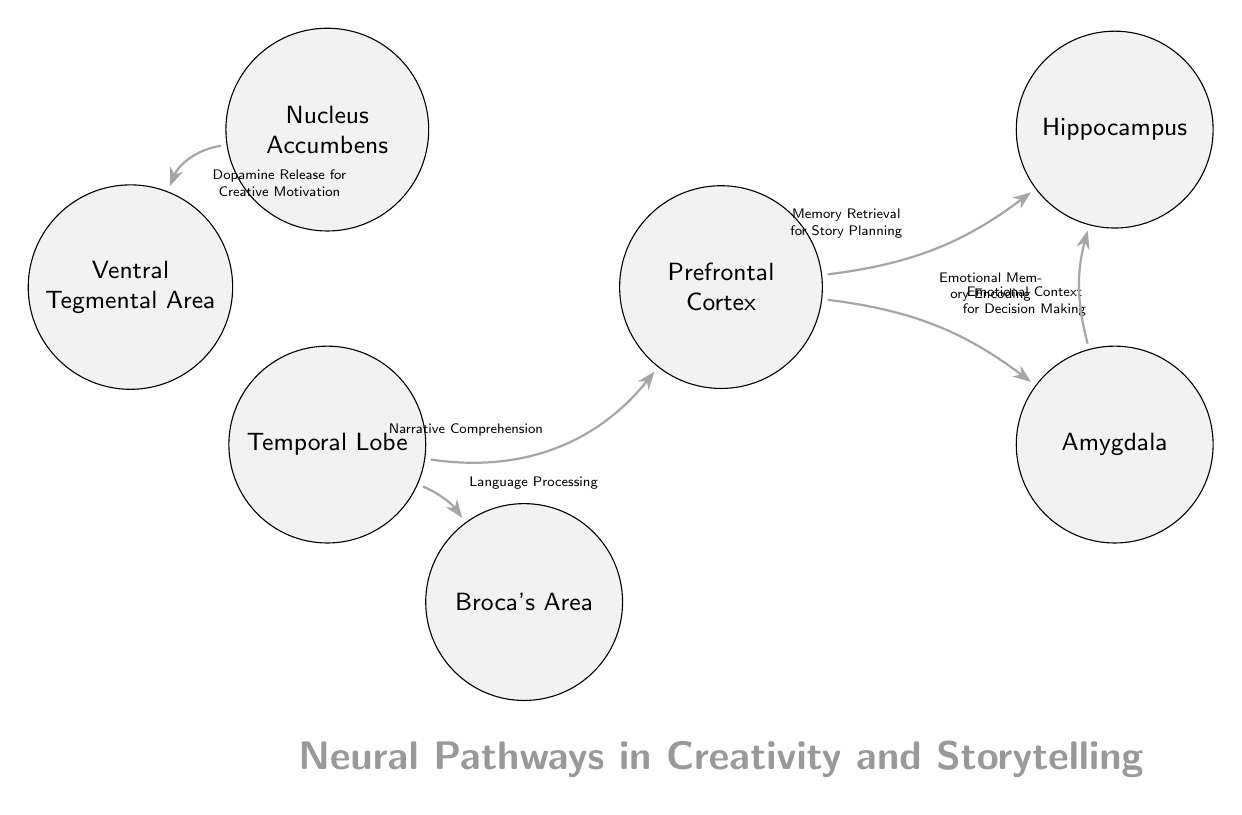What is the central brain area involved in memory retrieval for story planning? The diagram identifies the Prefrontal Cortex as a key area linked to memory retrieval for planning stories, as indicated by the labeled connection between the PFC and Hippocampus.
Answer: Prefrontal Cortex Which brain region is responsible for emotional memory encoding? According to the diagram, the connection from the Amygdala to the Hippocampus illustrates that the Amygdala plays a role in encoding emotional memories.
Answer: Amygdala How many connections are shown in the diagram? By inspecting the connections displayed between the brain regions, we can count a total of 5 connections in the diagram.
Answer: 5 What emotion-related function is associated with the Prefrontal Cortex? The diagram shows that the Prefrontal Cortex is connected to the Amygdala, which is described as providing emotional context for decision making; therefore, this function relates to emotional aspects.
Answer: Emotional Context for Decision Making Which area is connected to the Temporal Lobe for narrative comprehension? The diagram indicates that there is a direct connection between the Temporal Lobe and the Prefrontal Cortex specifically for the function of narrative comprehension.
Answer: Prefrontal Cortex What neurotransmitter is involved in creative motivation as per the diagram? The connection representing the flow from the Nucleus Accumbens to the Ventral Tegmental Area suggests that dopamine is the neurotransmitter involved in promoting creative motivation.
Answer: Dopamine What brain area processes language related to storytelling? The diagram shows a connection from the Temporal Lobe to Broca's Area, highlighting that Broca's Area is involved in language processing.
Answer: Broca's Area Explain the relationship between the Temporal Lobe and the Prefrontal Cortex. The diagram illustrates that the Temporal Lobe connects to the Prefrontal Cortex, which involves narrative comprehension, suggesting that the Temporal Lobe aids the Prefrontal Cortex in understanding and constructing narratives by processing relevant language.
Answer: Narrative Comprehension Which part of the brain is connected to dopamine release for creative motivation? The Nucleus Accumbens is linked to the Ventral Tegmental Area in the diagram, indicating that this connection is crucial for dopamine release related to creative motivation.
Answer: Nucleus Accumbens 